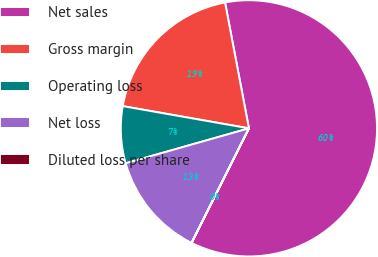Convert chart. <chart><loc_0><loc_0><loc_500><loc_500><pie_chart><fcel>Net sales<fcel>Gross margin<fcel>Operating loss<fcel>Net loss<fcel>Diluted loss per share<nl><fcel>60.36%<fcel>19.24%<fcel>7.17%<fcel>13.21%<fcel>0.01%<nl></chart> 